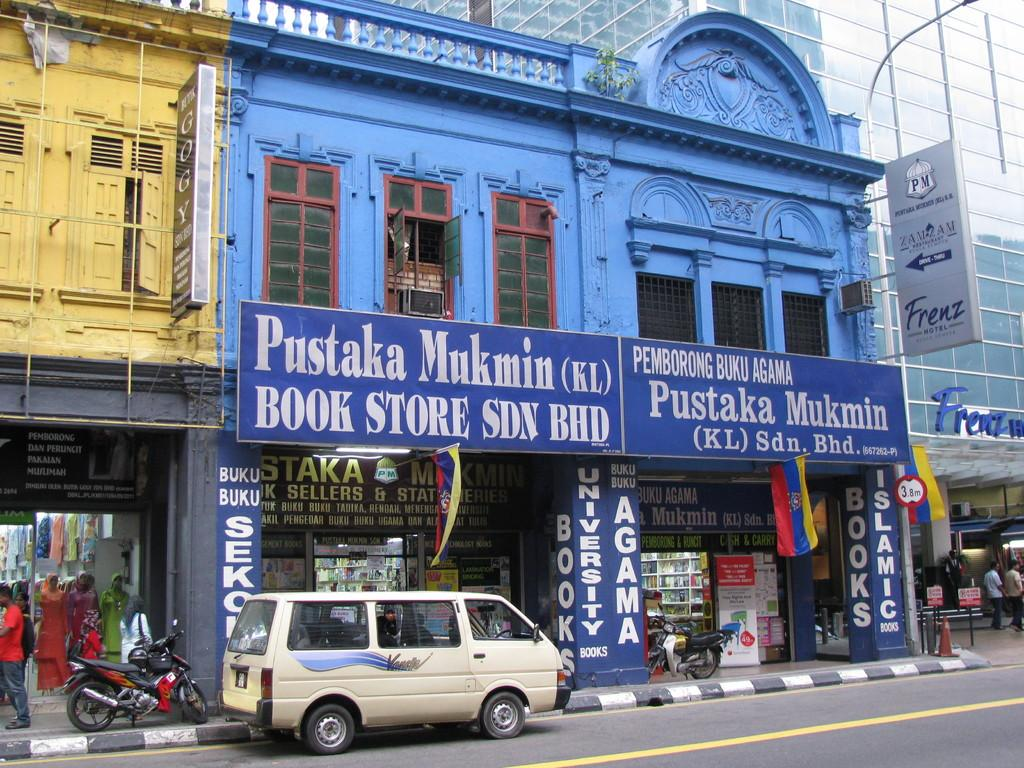<image>
Relay a brief, clear account of the picture shown. A tan van is parked outside a blue building that says Pustaka Mukmin Book Store. 